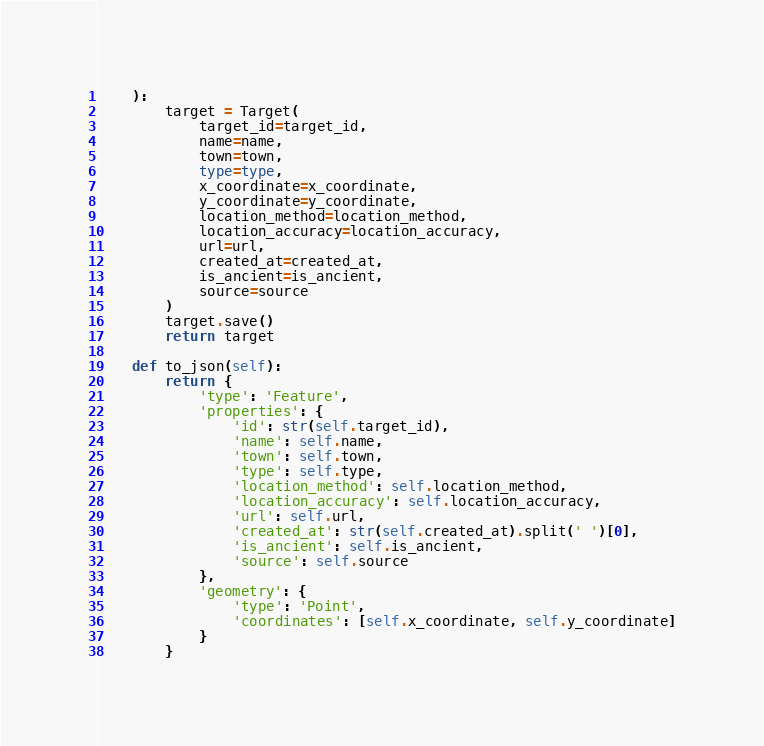<code> <loc_0><loc_0><loc_500><loc_500><_Python_>    ):
        target = Target(
            target_id=target_id,
            name=name,
            town=town,
            type=type,
            x_coordinate=x_coordinate,
            y_coordinate=y_coordinate,
            location_method=location_method,
            location_accuracy=location_accuracy,
            url=url,
            created_at=created_at,
            is_ancient=is_ancient,
            source=source
        )
        target.save()
        return target

    def to_json(self):
        return {
            'type': 'Feature',
            'properties': {
                'id': str(self.target_id),
                'name': self.name,
                'town': self.town,
                'type': self.type,
                'location_method': self.location_method,
                'location_accuracy': self.location_accuracy,
                'url': self.url,
                'created_at': str(self.created_at).split(' ')[0],
                'is_ancient': self.is_ancient,
                'source': self.source
            },
            'geometry': {
                'type': 'Point',
                'coordinates': [self.x_coordinate, self.y_coordinate]
            }
        }
</code> 